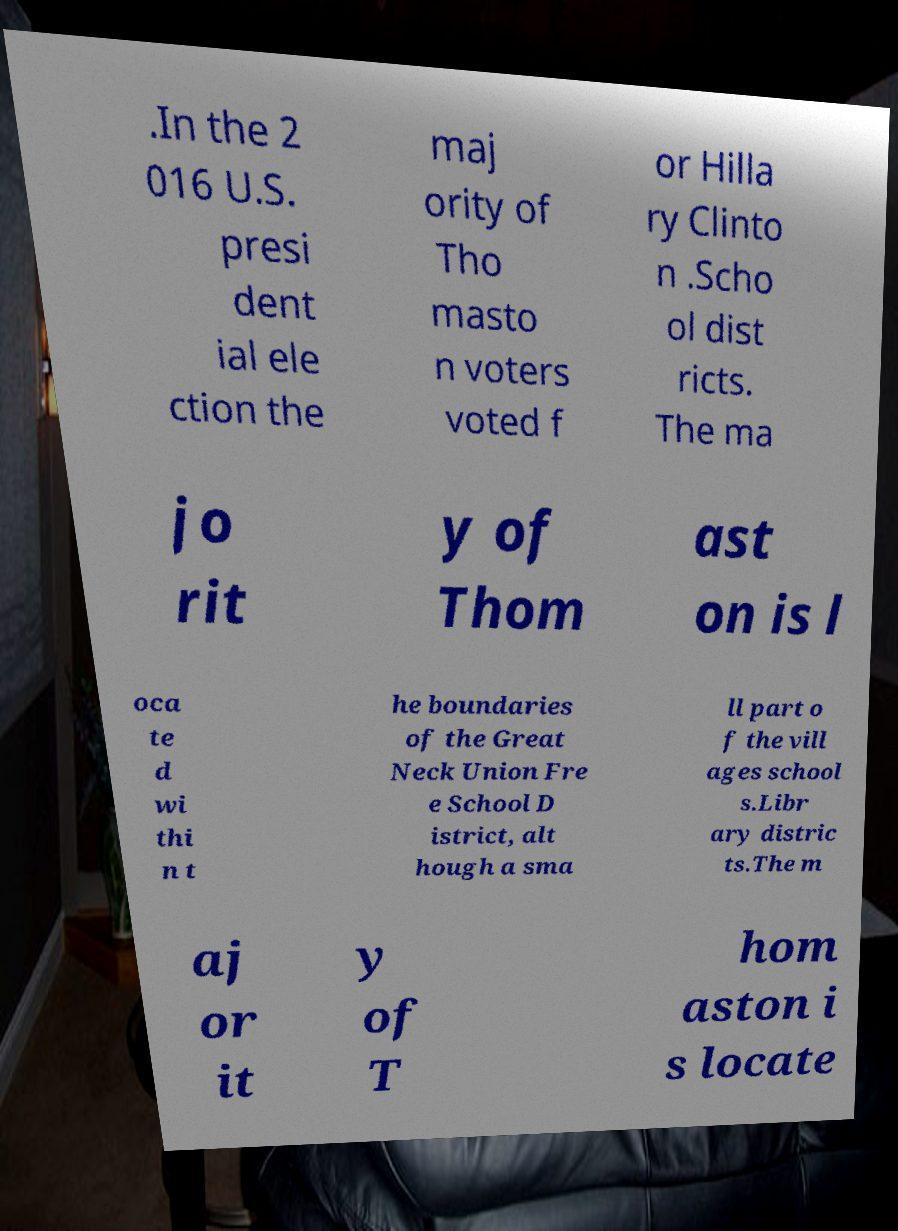Please read and relay the text visible in this image. What does it say? .In the 2 016 U.S. presi dent ial ele ction the maj ority of Tho masto n voters voted f or Hilla ry Clinto n .Scho ol dist ricts. The ma jo rit y of Thom ast on is l oca te d wi thi n t he boundaries of the Great Neck Union Fre e School D istrict, alt hough a sma ll part o f the vill ages school s.Libr ary distric ts.The m aj or it y of T hom aston i s locate 